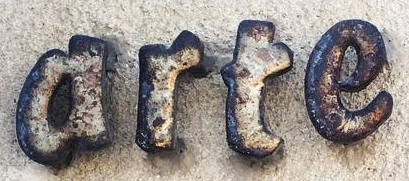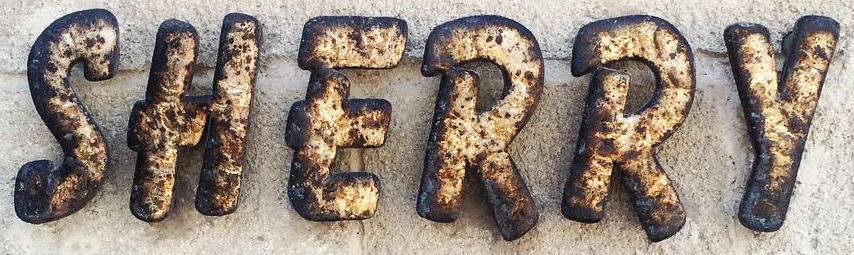What words can you see in these images in sequence, separated by a semicolon? arte; SHERRY 